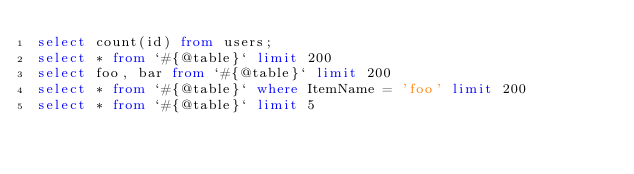Convert code to text. <code><loc_0><loc_0><loc_500><loc_500><_SQL_>select count(id) from users;
select * from `#{@table}` limit 200
select foo, bar from `#{@table}` limit 200
select * from `#{@table}` where ItemName = 'foo' limit 200
select * from `#{@table}` limit 5
</code> 